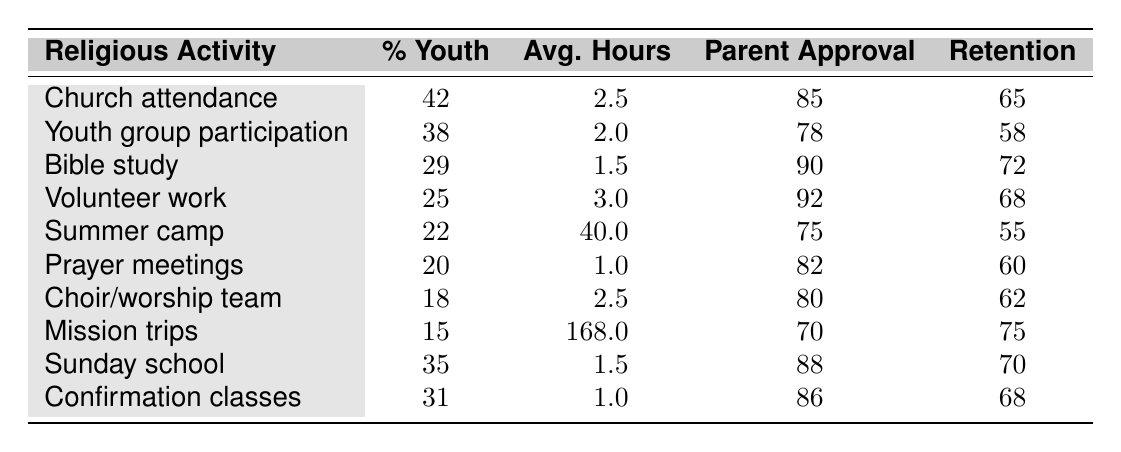What is the percentage of youth involved in church attendance? The table lists the percentage of youth involved in church attendance as 42%.
Answer: 42% Which religious activity has the highest parental approval rating? By scanning the table, volunteer work has the highest parental approval rating at 92%.
Answer: Volunteer work What is the average number of hours youth spend on summer camp activities? The table indicates that the average hours youth spend on summer camp is 40.0 hours per week.
Answer: 40.0 hours Is the retention rate into adulthood for Bible study greater than for confirmation classes? The retention rate for Bible study is 72, while for confirmation classes it is 68. Therefore, Bible study does have a higher retention rate.
Answer: Yes What is the difference between the percentage of youth involved in choir/worship team and mission trips? The percentage for choir/worship team is 18%, and for mission trips, it is 15%. The difference is 18% - 15% = 3%.
Answer: 3% What is the total percentage of youth involved in volunteer work and prayer meetings? The percentage for volunteer work is 25%, and for prayer meetings, it is 20%. Summing these gives 25% + 20% = 45%.
Answer: 45% If a youth participates in Bible study and confirmation classes, what is the average parental approval rating? The approval ratings are 90 for Bible study and 86 for confirmation classes. The average is (90 + 86) / 2 = 88.
Answer: 88 How many hours per week do youth spend on activities with the lowest parental approval rating? The activity with the lowest parental approval is for mission trips, which has an average of 168.0 hours per week.
Answer: 168.0 hours For which activity is youth involvement closest to the retention rate into adulthood? For youth group participation, the percentage involved is 38, which is closest to the retention rate of 58.
Answer: Youth group participation What is the average parental approval rating for all listed activities? To find the average, add all parental approval ratings (85 + 78 + 90 + 92 + 75 + 82 + 80 + 70 + 88 + 86 =  829) and divide by the number of activities (10). The average is 829 / 10 = 82.9.
Answer: 82.9 